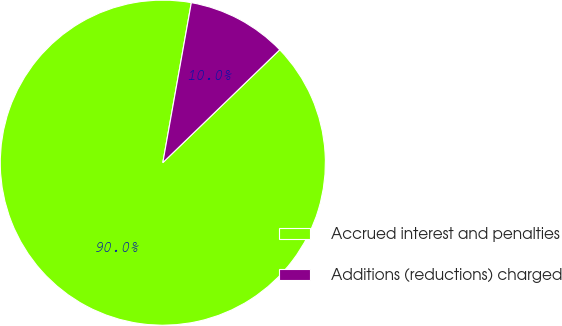Convert chart. <chart><loc_0><loc_0><loc_500><loc_500><pie_chart><fcel>Accrued interest and penalties<fcel>Additions (reductions) charged<nl><fcel>90.03%<fcel>9.97%<nl></chart> 